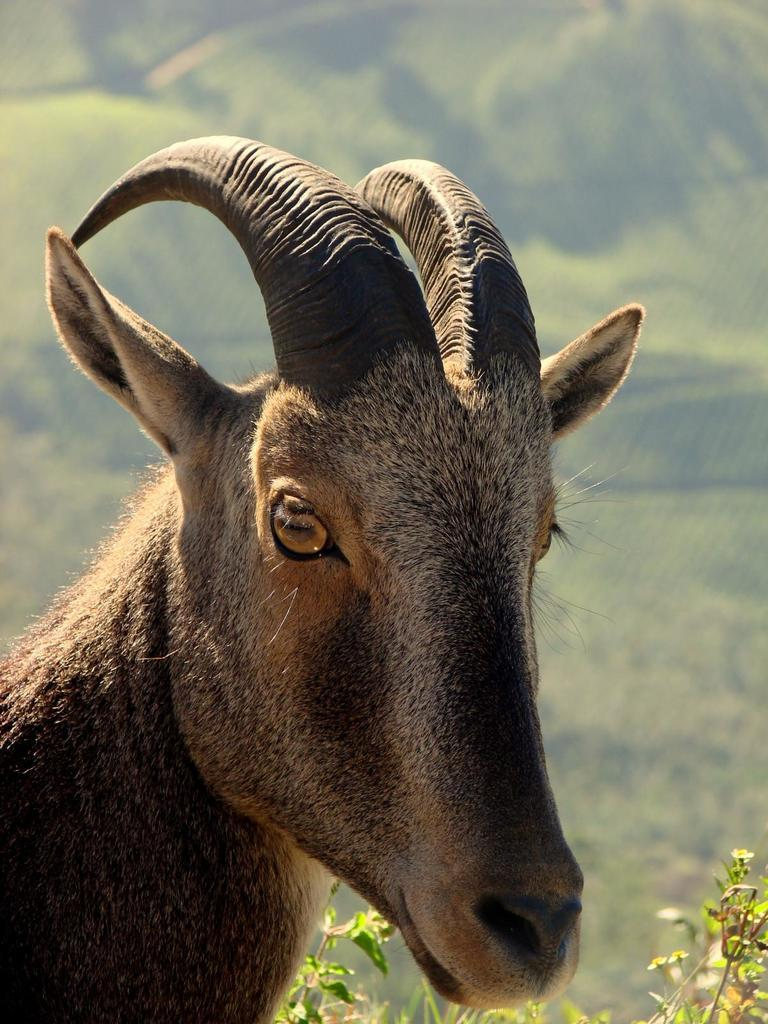What type of living creature is present in the image? There is an animal in the image. What other elements can be seen in the image besides the animal? There are plants in the image. Can you describe the background of the image? The background of the image is blurred. What type of pear is the cook using to prepare the dish in the image? There is no cook or pear present in the image; it only features an animal and plants. 